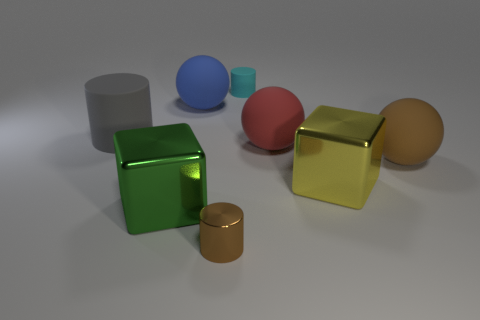What is the large ball that is both on the right side of the tiny cyan matte object and to the left of the large brown sphere made of?
Offer a terse response. Rubber. Is the size of the metal object right of the cyan object the same as the tiny rubber object?
Provide a short and direct response. No. Is the number of objects on the left side of the tiny matte thing greater than the number of red spheres in front of the brown metallic cylinder?
Your answer should be compact. Yes. There is a tiny cylinder that is in front of the large sphere that is to the left of the metal thing that is in front of the green cube; what color is it?
Provide a short and direct response. Brown. There is a large ball on the right side of the large yellow metal object; is its color the same as the small shiny object?
Offer a terse response. Yes. How many other things are the same color as the big rubber cylinder?
Make the answer very short. 0. How many objects are either blue rubber spheres or big blue metallic cylinders?
Provide a short and direct response. 1. What number of objects are green blocks or spheres that are left of the big brown rubber thing?
Your answer should be compact. 3. Do the brown sphere and the green cube have the same material?
Provide a succinct answer. No. How many other objects are the same material as the red object?
Keep it short and to the point. 4. 